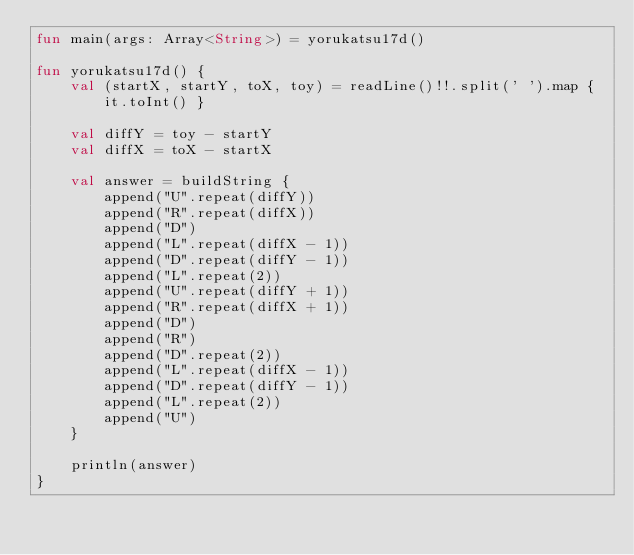Convert code to text. <code><loc_0><loc_0><loc_500><loc_500><_Kotlin_>fun main(args: Array<String>) = yorukatsu17d()

fun yorukatsu17d() {
    val (startX, startY, toX, toy) = readLine()!!.split(' ').map { it.toInt() }

    val diffY = toy - startY
    val diffX = toX - startX

    val answer = buildString {
        append("U".repeat(diffY))
        append("R".repeat(diffX))
        append("D")
        append("L".repeat(diffX - 1))
        append("D".repeat(diffY - 1))
        append("L".repeat(2))
        append("U".repeat(diffY + 1))
        append("R".repeat(diffX + 1))
        append("D")
        append("R")
        append("D".repeat(2))
        append("L".repeat(diffX - 1))
        append("D".repeat(diffY - 1))
        append("L".repeat(2))
        append("U")
    }

    println(answer)
}
</code> 